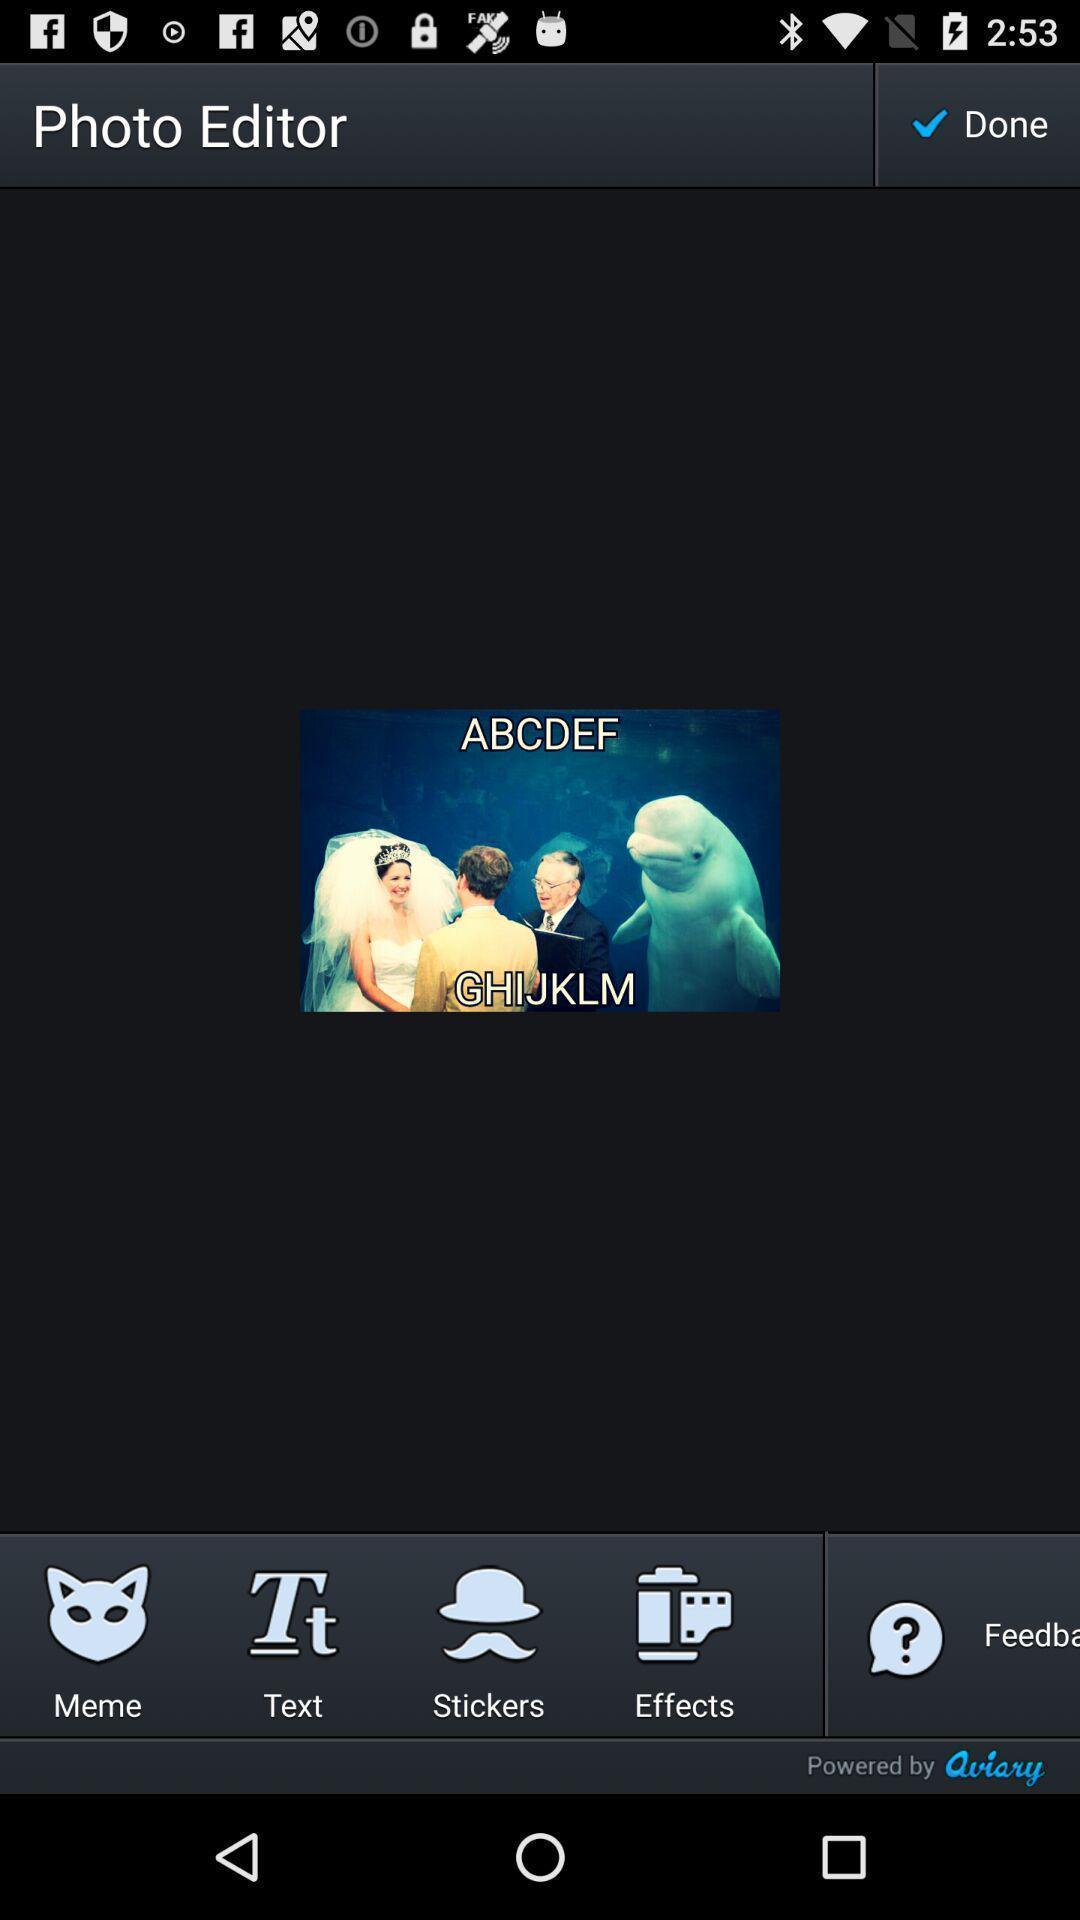Describe this image in words. Screen showing image in an editing application. 